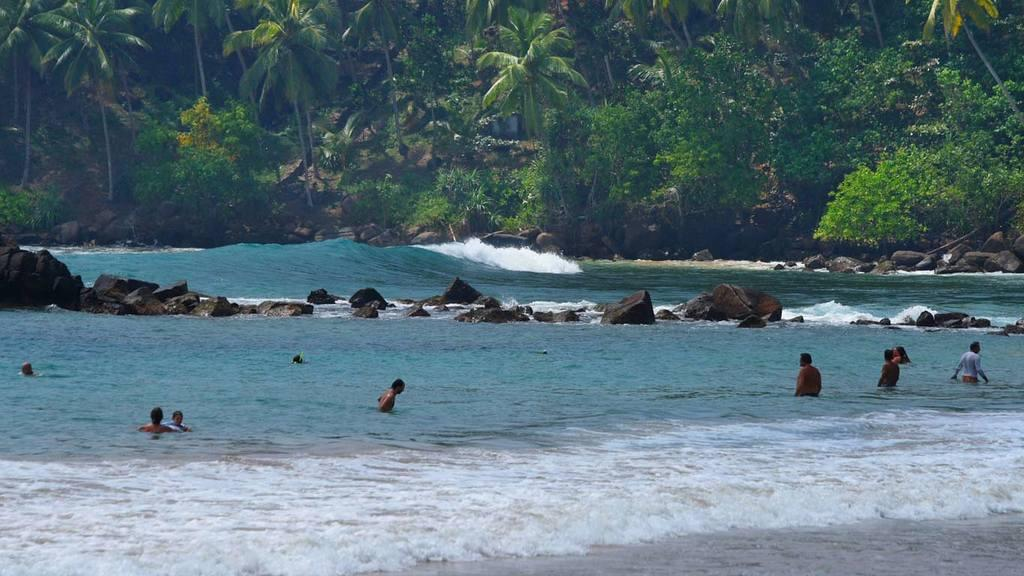What are the people in the image doing? The people in the image are in the water. What can be seen in the center of the image? There are rocks in the center of the image. What type of vegetation is visible in the background? There is a group of trees and plants visible in the background. Can you hear the airplane flying over the people in the image? There is no airplane present in the image, so we cannot hear it flying over the people. Is there a tiger visible in the image? No, there is no tiger present in the image. 